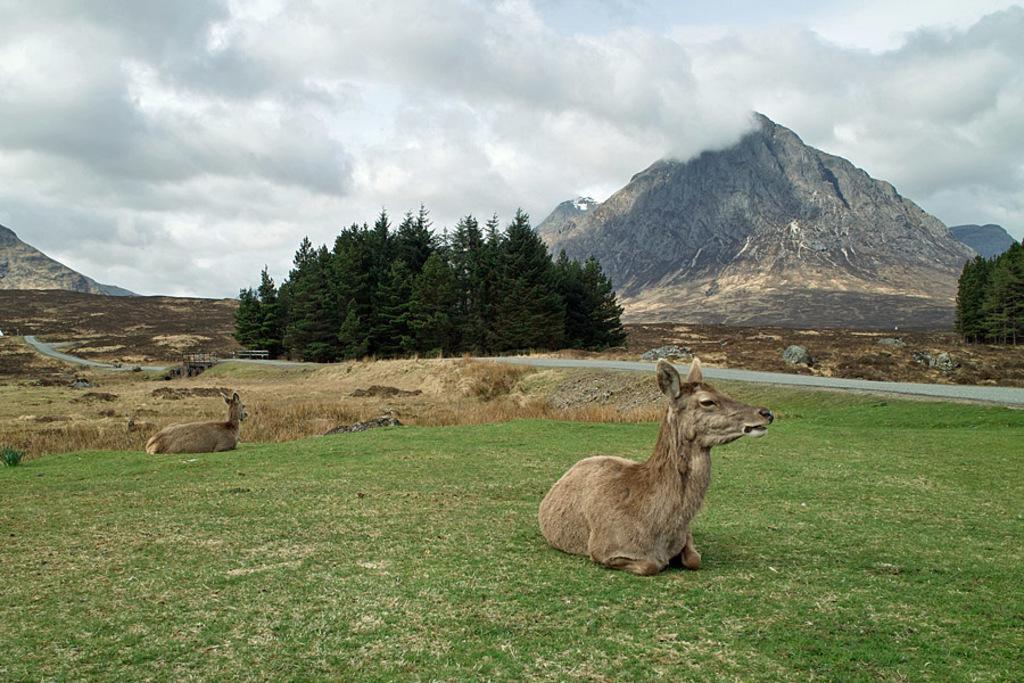Describe this image in one or two sentences. In this image we can see two animals are sitting on the grassland. Here we can see the road, trees, hills and the sky with clouds in the background. 